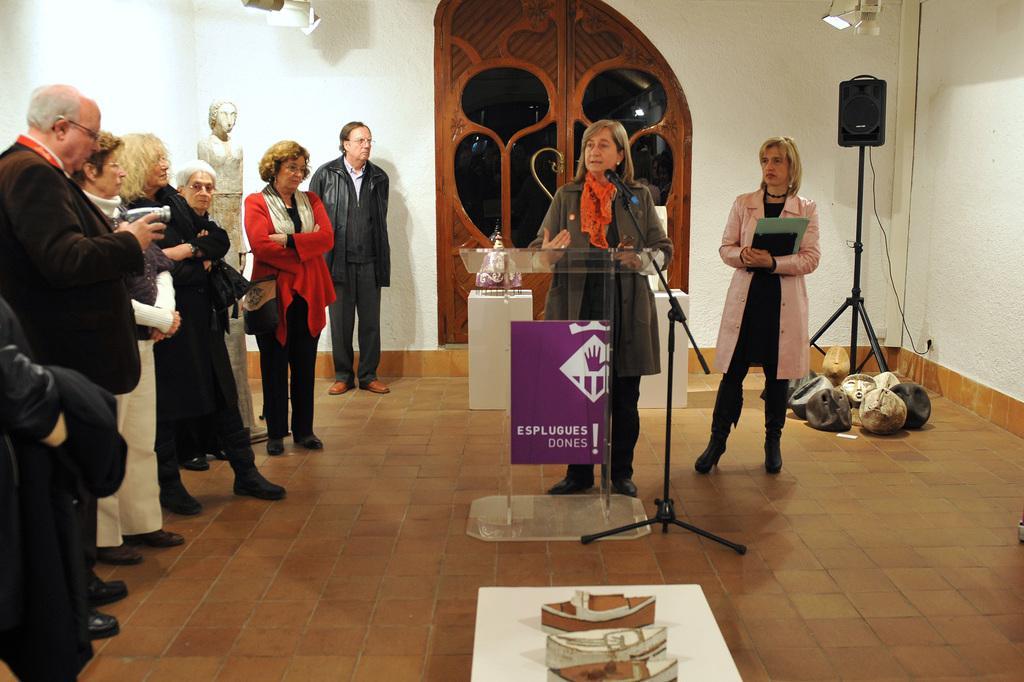Could you give a brief overview of what you see in this image? This picture is inside view of a room. In the center of the image we can see a podium, a lady is standing, a mic stand are there. On the right side of the image a lady is standing and holding an object, speaker, light, wall are present. On the left side of the image some persons, statue are there. At the bottom of the image floor is there. At the top of the image door is present. 